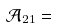<formula> <loc_0><loc_0><loc_500><loc_500>\mathcal { A } _ { 2 1 } =</formula> 